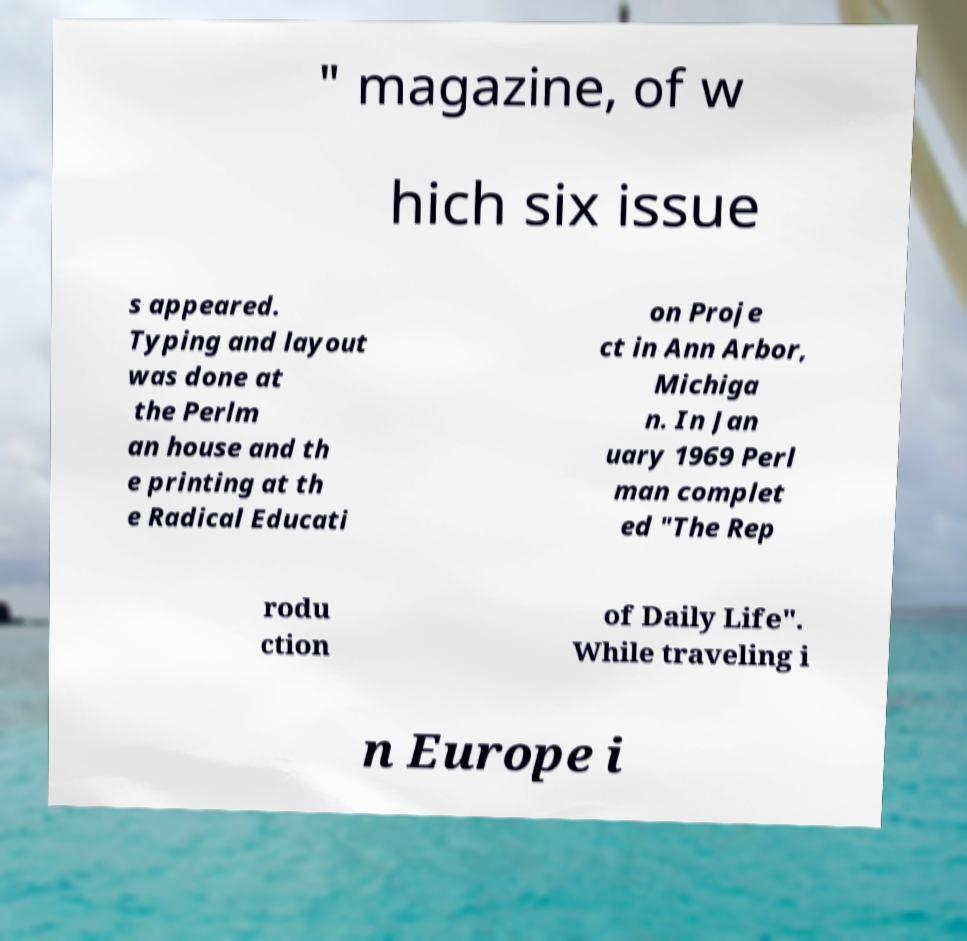Please read and relay the text visible in this image. What does it say? " magazine, of w hich six issue s appeared. Typing and layout was done at the Perlm an house and th e printing at th e Radical Educati on Proje ct in Ann Arbor, Michiga n. In Jan uary 1969 Perl man complet ed "The Rep rodu ction of Daily Life". While traveling i n Europe i 